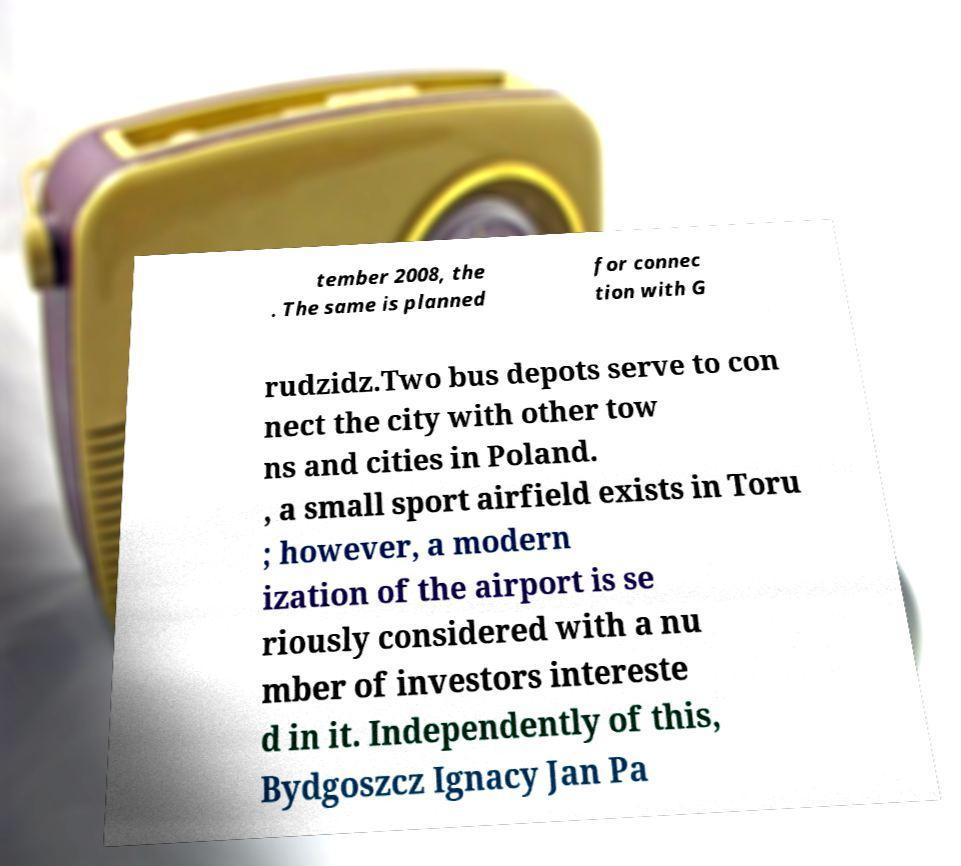Can you read and provide the text displayed in the image?This photo seems to have some interesting text. Can you extract and type it out for me? tember 2008, the . The same is planned for connec tion with G rudzidz.Two bus depots serve to con nect the city with other tow ns and cities in Poland. , a small sport airfield exists in Toru ; however, a modern ization of the airport is se riously considered with a nu mber of investors intereste d in it. Independently of this, Bydgoszcz Ignacy Jan Pa 